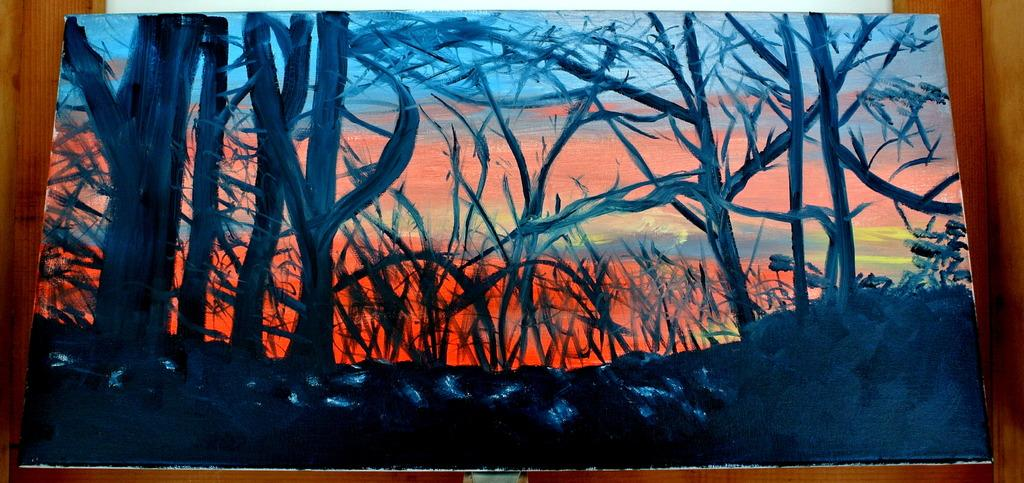What type of artwork is depicted in the image? The image is a painted frame. What can be seen in the foreground of the image? There are trees and plants in the foreground of the image. What is visible in the background of the image? The sky is visible in the background of the image. What type of vest can be seen hanging from the trees in the image? There is no vest present in the image; it features trees and plants in the foreground. How many cats are visible in the image? There are no cats present in the image; it features trees, plants, and a painted frame. 